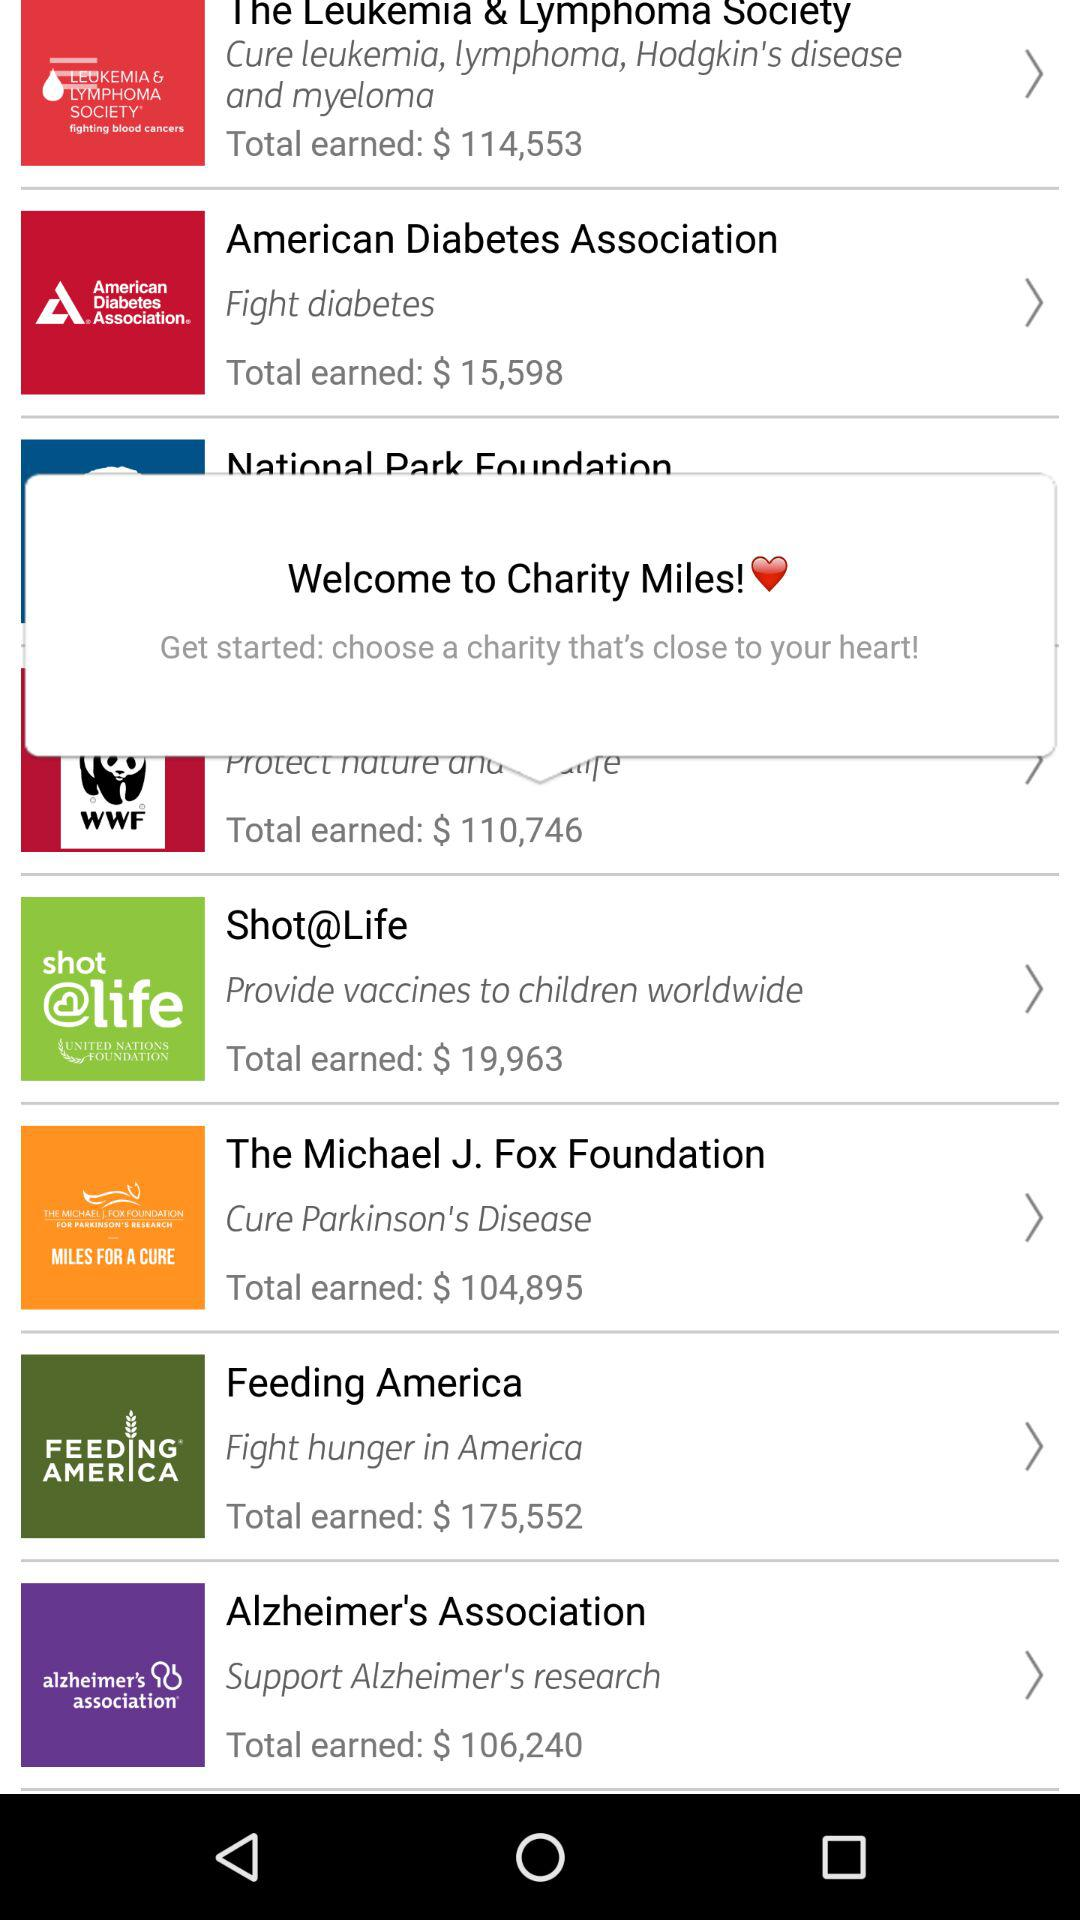What is the total amount earned by the "American Diabetes Association"? The total amount earned by the "American Diabetes Association" is $15,598. 